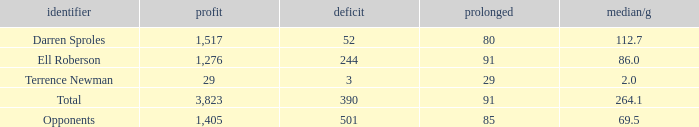When the Gain is 29, and the average per game is 2, and the player lost less than 390 yards, what's the sum of the Long yards? None. 